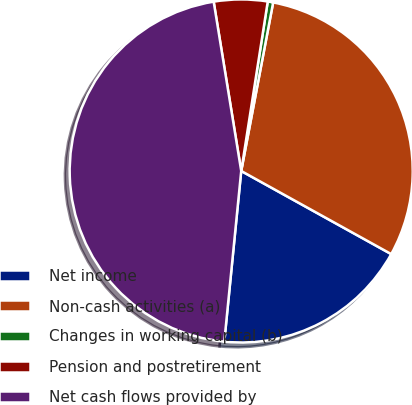Convert chart to OTSL. <chart><loc_0><loc_0><loc_500><loc_500><pie_chart><fcel>Net income<fcel>Non-cash activities (a)<fcel>Changes in working capital (b)<fcel>Pension and postretirement<fcel>Net cash flows provided by<nl><fcel>18.52%<fcel>30.07%<fcel>0.51%<fcel>5.04%<fcel>45.86%<nl></chart> 